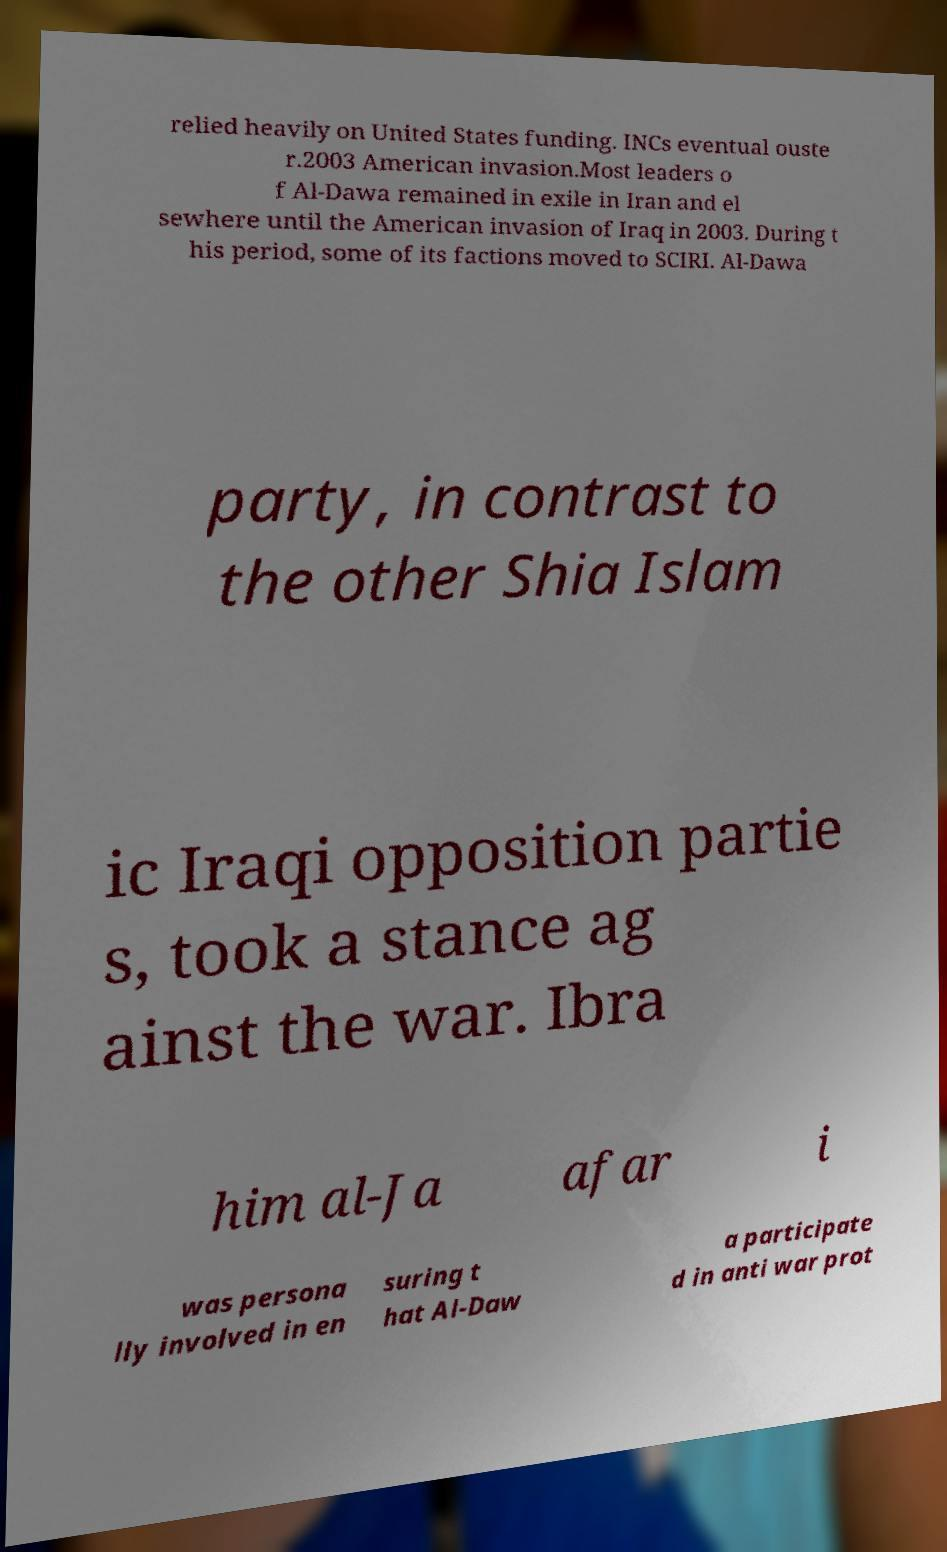Please read and relay the text visible in this image. What does it say? relied heavily on United States funding. INCs eventual ouste r.2003 American invasion.Most leaders o f Al-Dawa remained in exile in Iran and el sewhere until the American invasion of Iraq in 2003. During t his period, some of its factions moved to SCIRI. Al-Dawa party, in contrast to the other Shia Islam ic Iraqi opposition partie s, took a stance ag ainst the war. Ibra him al-Ja afar i was persona lly involved in en suring t hat Al-Daw a participate d in anti war prot 